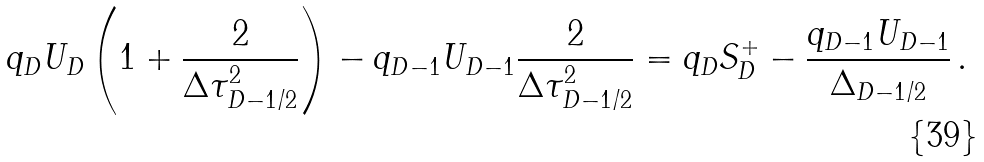<formula> <loc_0><loc_0><loc_500><loc_500>q _ { D } U _ { D } \left ( 1 + \frac { 2 } { \Delta \tau _ { D - 1 / 2 } ^ { 2 } } \right ) - q _ { D - 1 } U _ { D - 1 } \frac { 2 } { \Delta \tau _ { D - 1 / 2 } ^ { 2 } } = q _ { D } S ^ { + } _ { D } - \frac { q _ { D - 1 } U _ { D - 1 } } { \Delta _ { D - 1 / 2 } } \, .</formula> 